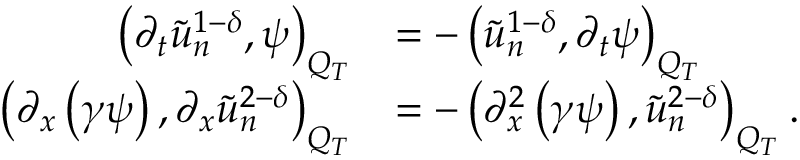<formula> <loc_0><loc_0><loc_500><loc_500>\begin{array} { r l } { \left ( \partial _ { t } \tilde { u } _ { n } ^ { 1 - \delta } , \psi \right ) _ { Q _ { T } } } & { = - \left ( \tilde { u } _ { n } ^ { 1 - \delta } , \partial _ { t } \psi \right ) _ { Q _ { T } } } \\ { \left ( \partial _ { x } \left ( \gamma \psi \right ) , \partial _ { x } \tilde { u } _ { n } ^ { 2 - \delta } \right ) _ { Q _ { T } } } & { = - \left ( \partial _ { x } ^ { 2 } \left ( \gamma \psi \right ) , \tilde { u } _ { n } ^ { 2 - \delta } \right ) _ { Q _ { T } } . } \end{array}</formula> 